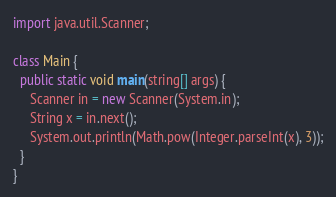<code> <loc_0><loc_0><loc_500><loc_500><_Java_>import java.util.Scanner;

class Main {
  public static void main(string[] args) {
     Scanner in = new Scanner(System.in);
     String x = in.next();
     System.out.println(Math.pow(Integer.parseInt(x), 3));
  }
}</code> 